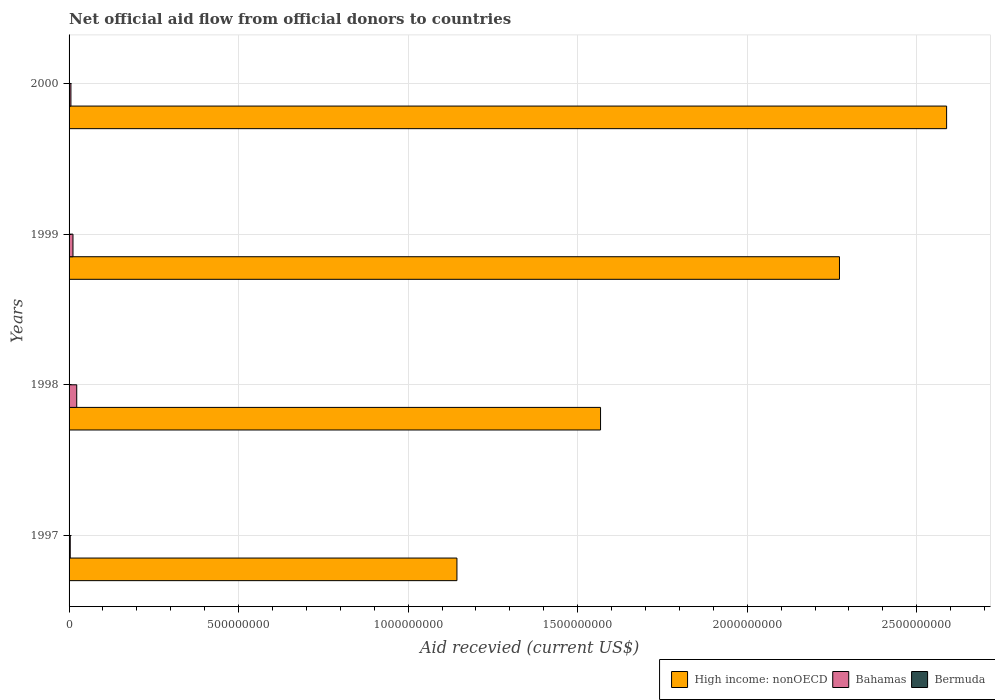How many different coloured bars are there?
Your response must be concise. 3. How many groups of bars are there?
Your response must be concise. 4. Are the number of bars per tick equal to the number of legend labels?
Provide a succinct answer. No. Are the number of bars on each tick of the Y-axis equal?
Your answer should be compact. No. What is the label of the 4th group of bars from the top?
Your answer should be very brief. 1997. What is the total aid received in High income: nonOECD in 1998?
Your response must be concise. 1.57e+09. Across all years, what is the maximum total aid received in Bahamas?
Offer a very short reply. 2.26e+07. Across all years, what is the minimum total aid received in High income: nonOECD?
Your answer should be compact. 1.14e+09. In which year was the total aid received in Bermuda maximum?
Provide a succinct answer. 1998. What is the total total aid received in High income: nonOECD in the graph?
Offer a terse response. 7.57e+09. What is the difference between the total aid received in Bahamas in 1997 and that in 1998?
Provide a succinct answer. -1.91e+07. What is the difference between the total aid received in High income: nonOECD in 2000 and the total aid received in Bermuda in 1998?
Provide a succinct answer. 2.59e+09. What is the average total aid received in Bermuda per year?
Your answer should be very brief. 1.72e+05. In the year 1998, what is the difference between the total aid received in High income: nonOECD and total aid received in Bahamas?
Offer a terse response. 1.54e+09. In how many years, is the total aid received in Bermuda greater than 1000000000 US$?
Provide a succinct answer. 0. What is the ratio of the total aid received in High income: nonOECD in 1998 to that in 2000?
Make the answer very short. 0.61. In how many years, is the total aid received in High income: nonOECD greater than the average total aid received in High income: nonOECD taken over all years?
Your answer should be very brief. 2. Is the sum of the total aid received in Bermuda in 1998 and 1999 greater than the maximum total aid received in High income: nonOECD across all years?
Your answer should be very brief. No. Is it the case that in every year, the sum of the total aid received in High income: nonOECD and total aid received in Bermuda is greater than the total aid received in Bahamas?
Your answer should be compact. Yes. Are all the bars in the graph horizontal?
Your answer should be compact. Yes. What is the difference between two consecutive major ticks on the X-axis?
Give a very brief answer. 5.00e+08. Are the values on the major ticks of X-axis written in scientific E-notation?
Keep it short and to the point. No. Does the graph contain any zero values?
Your response must be concise. Yes. Does the graph contain grids?
Your response must be concise. Yes. Where does the legend appear in the graph?
Ensure brevity in your answer.  Bottom right. How many legend labels are there?
Offer a very short reply. 3. How are the legend labels stacked?
Ensure brevity in your answer.  Horizontal. What is the title of the graph?
Your response must be concise. Net official aid flow from official donors to countries. What is the label or title of the X-axis?
Your answer should be compact. Aid recevied (current US$). What is the label or title of the Y-axis?
Offer a very short reply. Years. What is the Aid recevied (current US$) of High income: nonOECD in 1997?
Your answer should be compact. 1.14e+09. What is the Aid recevied (current US$) of Bahamas in 1997?
Provide a short and direct response. 3.47e+06. What is the Aid recevied (current US$) of High income: nonOECD in 1998?
Your response must be concise. 1.57e+09. What is the Aid recevied (current US$) in Bahamas in 1998?
Your answer should be very brief. 2.26e+07. What is the Aid recevied (current US$) of High income: nonOECD in 1999?
Keep it short and to the point. 2.27e+09. What is the Aid recevied (current US$) of Bahamas in 1999?
Provide a succinct answer. 1.16e+07. What is the Aid recevied (current US$) in Bermuda in 1999?
Keep it short and to the point. 8.00e+04. What is the Aid recevied (current US$) in High income: nonOECD in 2000?
Keep it short and to the point. 2.59e+09. What is the Aid recevied (current US$) in Bahamas in 2000?
Ensure brevity in your answer.  5.47e+06. What is the Aid recevied (current US$) in Bermuda in 2000?
Your response must be concise. 6.00e+04. Across all years, what is the maximum Aid recevied (current US$) of High income: nonOECD?
Your answer should be very brief. 2.59e+09. Across all years, what is the maximum Aid recevied (current US$) of Bahamas?
Your answer should be compact. 2.26e+07. Across all years, what is the minimum Aid recevied (current US$) of High income: nonOECD?
Ensure brevity in your answer.  1.14e+09. Across all years, what is the minimum Aid recevied (current US$) of Bahamas?
Offer a very short reply. 3.47e+06. What is the total Aid recevied (current US$) of High income: nonOECD in the graph?
Ensure brevity in your answer.  7.57e+09. What is the total Aid recevied (current US$) in Bahamas in the graph?
Your answer should be compact. 4.31e+07. What is the total Aid recevied (current US$) in Bermuda in the graph?
Keep it short and to the point. 6.90e+05. What is the difference between the Aid recevied (current US$) of High income: nonOECD in 1997 and that in 1998?
Offer a terse response. -4.24e+08. What is the difference between the Aid recevied (current US$) of Bahamas in 1997 and that in 1998?
Make the answer very short. -1.91e+07. What is the difference between the Aid recevied (current US$) of High income: nonOECD in 1997 and that in 1999?
Keep it short and to the point. -1.13e+09. What is the difference between the Aid recevied (current US$) of Bahamas in 1997 and that in 1999?
Provide a succinct answer. -8.09e+06. What is the difference between the Aid recevied (current US$) of High income: nonOECD in 1997 and that in 2000?
Keep it short and to the point. -1.44e+09. What is the difference between the Aid recevied (current US$) of Bahamas in 1997 and that in 2000?
Provide a succinct answer. -2.00e+06. What is the difference between the Aid recevied (current US$) in High income: nonOECD in 1998 and that in 1999?
Make the answer very short. -7.05e+08. What is the difference between the Aid recevied (current US$) of Bahamas in 1998 and that in 1999?
Your answer should be compact. 1.10e+07. What is the difference between the Aid recevied (current US$) in High income: nonOECD in 1998 and that in 2000?
Provide a short and direct response. -1.02e+09. What is the difference between the Aid recevied (current US$) of Bahamas in 1998 and that in 2000?
Offer a very short reply. 1.71e+07. What is the difference between the Aid recevied (current US$) in High income: nonOECD in 1999 and that in 2000?
Give a very brief answer. -3.16e+08. What is the difference between the Aid recevied (current US$) of Bahamas in 1999 and that in 2000?
Ensure brevity in your answer.  6.09e+06. What is the difference between the Aid recevied (current US$) of High income: nonOECD in 1997 and the Aid recevied (current US$) of Bahamas in 1998?
Keep it short and to the point. 1.12e+09. What is the difference between the Aid recevied (current US$) of High income: nonOECD in 1997 and the Aid recevied (current US$) of Bermuda in 1998?
Keep it short and to the point. 1.14e+09. What is the difference between the Aid recevied (current US$) of Bahamas in 1997 and the Aid recevied (current US$) of Bermuda in 1998?
Your answer should be compact. 2.92e+06. What is the difference between the Aid recevied (current US$) in High income: nonOECD in 1997 and the Aid recevied (current US$) in Bahamas in 1999?
Offer a terse response. 1.13e+09. What is the difference between the Aid recevied (current US$) in High income: nonOECD in 1997 and the Aid recevied (current US$) in Bermuda in 1999?
Make the answer very short. 1.14e+09. What is the difference between the Aid recevied (current US$) of Bahamas in 1997 and the Aid recevied (current US$) of Bermuda in 1999?
Offer a very short reply. 3.39e+06. What is the difference between the Aid recevied (current US$) of High income: nonOECD in 1997 and the Aid recevied (current US$) of Bahamas in 2000?
Keep it short and to the point. 1.14e+09. What is the difference between the Aid recevied (current US$) of High income: nonOECD in 1997 and the Aid recevied (current US$) of Bermuda in 2000?
Provide a short and direct response. 1.14e+09. What is the difference between the Aid recevied (current US$) in Bahamas in 1997 and the Aid recevied (current US$) in Bermuda in 2000?
Give a very brief answer. 3.41e+06. What is the difference between the Aid recevied (current US$) of High income: nonOECD in 1998 and the Aid recevied (current US$) of Bahamas in 1999?
Your answer should be compact. 1.56e+09. What is the difference between the Aid recevied (current US$) in High income: nonOECD in 1998 and the Aid recevied (current US$) in Bermuda in 1999?
Offer a terse response. 1.57e+09. What is the difference between the Aid recevied (current US$) in Bahamas in 1998 and the Aid recevied (current US$) in Bermuda in 1999?
Your answer should be very brief. 2.25e+07. What is the difference between the Aid recevied (current US$) in High income: nonOECD in 1998 and the Aid recevied (current US$) in Bahamas in 2000?
Offer a terse response. 1.56e+09. What is the difference between the Aid recevied (current US$) in High income: nonOECD in 1998 and the Aid recevied (current US$) in Bermuda in 2000?
Offer a terse response. 1.57e+09. What is the difference between the Aid recevied (current US$) of Bahamas in 1998 and the Aid recevied (current US$) of Bermuda in 2000?
Offer a terse response. 2.26e+07. What is the difference between the Aid recevied (current US$) in High income: nonOECD in 1999 and the Aid recevied (current US$) in Bahamas in 2000?
Provide a short and direct response. 2.27e+09. What is the difference between the Aid recevied (current US$) in High income: nonOECD in 1999 and the Aid recevied (current US$) in Bermuda in 2000?
Give a very brief answer. 2.27e+09. What is the difference between the Aid recevied (current US$) in Bahamas in 1999 and the Aid recevied (current US$) in Bermuda in 2000?
Offer a very short reply. 1.15e+07. What is the average Aid recevied (current US$) in High income: nonOECD per year?
Your response must be concise. 1.89e+09. What is the average Aid recevied (current US$) of Bahamas per year?
Keep it short and to the point. 1.08e+07. What is the average Aid recevied (current US$) in Bermuda per year?
Ensure brevity in your answer.  1.72e+05. In the year 1997, what is the difference between the Aid recevied (current US$) of High income: nonOECD and Aid recevied (current US$) of Bahamas?
Provide a short and direct response. 1.14e+09. In the year 1998, what is the difference between the Aid recevied (current US$) in High income: nonOECD and Aid recevied (current US$) in Bahamas?
Give a very brief answer. 1.54e+09. In the year 1998, what is the difference between the Aid recevied (current US$) in High income: nonOECD and Aid recevied (current US$) in Bermuda?
Offer a very short reply. 1.57e+09. In the year 1998, what is the difference between the Aid recevied (current US$) of Bahamas and Aid recevied (current US$) of Bermuda?
Make the answer very short. 2.21e+07. In the year 1999, what is the difference between the Aid recevied (current US$) in High income: nonOECD and Aid recevied (current US$) in Bahamas?
Give a very brief answer. 2.26e+09. In the year 1999, what is the difference between the Aid recevied (current US$) in High income: nonOECD and Aid recevied (current US$) in Bermuda?
Keep it short and to the point. 2.27e+09. In the year 1999, what is the difference between the Aid recevied (current US$) of Bahamas and Aid recevied (current US$) of Bermuda?
Ensure brevity in your answer.  1.15e+07. In the year 2000, what is the difference between the Aid recevied (current US$) of High income: nonOECD and Aid recevied (current US$) of Bahamas?
Provide a short and direct response. 2.58e+09. In the year 2000, what is the difference between the Aid recevied (current US$) in High income: nonOECD and Aid recevied (current US$) in Bermuda?
Offer a very short reply. 2.59e+09. In the year 2000, what is the difference between the Aid recevied (current US$) of Bahamas and Aid recevied (current US$) of Bermuda?
Keep it short and to the point. 5.41e+06. What is the ratio of the Aid recevied (current US$) in High income: nonOECD in 1997 to that in 1998?
Provide a succinct answer. 0.73. What is the ratio of the Aid recevied (current US$) of Bahamas in 1997 to that in 1998?
Provide a short and direct response. 0.15. What is the ratio of the Aid recevied (current US$) in High income: nonOECD in 1997 to that in 1999?
Ensure brevity in your answer.  0.5. What is the ratio of the Aid recevied (current US$) in Bahamas in 1997 to that in 1999?
Your response must be concise. 0.3. What is the ratio of the Aid recevied (current US$) of High income: nonOECD in 1997 to that in 2000?
Your answer should be very brief. 0.44. What is the ratio of the Aid recevied (current US$) of Bahamas in 1997 to that in 2000?
Give a very brief answer. 0.63. What is the ratio of the Aid recevied (current US$) in High income: nonOECD in 1998 to that in 1999?
Keep it short and to the point. 0.69. What is the ratio of the Aid recevied (current US$) of Bahamas in 1998 to that in 1999?
Offer a terse response. 1.96. What is the ratio of the Aid recevied (current US$) of Bermuda in 1998 to that in 1999?
Offer a very short reply. 6.88. What is the ratio of the Aid recevied (current US$) in High income: nonOECD in 1998 to that in 2000?
Provide a succinct answer. 0.61. What is the ratio of the Aid recevied (current US$) of Bahamas in 1998 to that in 2000?
Offer a terse response. 4.13. What is the ratio of the Aid recevied (current US$) of Bermuda in 1998 to that in 2000?
Provide a short and direct response. 9.17. What is the ratio of the Aid recevied (current US$) in High income: nonOECD in 1999 to that in 2000?
Your answer should be compact. 0.88. What is the ratio of the Aid recevied (current US$) in Bahamas in 1999 to that in 2000?
Provide a succinct answer. 2.11. What is the ratio of the Aid recevied (current US$) in Bermuda in 1999 to that in 2000?
Provide a short and direct response. 1.33. What is the difference between the highest and the second highest Aid recevied (current US$) in High income: nonOECD?
Keep it short and to the point. 3.16e+08. What is the difference between the highest and the second highest Aid recevied (current US$) in Bahamas?
Make the answer very short. 1.10e+07. What is the difference between the highest and the second highest Aid recevied (current US$) in Bermuda?
Your response must be concise. 4.70e+05. What is the difference between the highest and the lowest Aid recevied (current US$) in High income: nonOECD?
Keep it short and to the point. 1.44e+09. What is the difference between the highest and the lowest Aid recevied (current US$) of Bahamas?
Offer a very short reply. 1.91e+07. What is the difference between the highest and the lowest Aid recevied (current US$) of Bermuda?
Make the answer very short. 5.50e+05. 